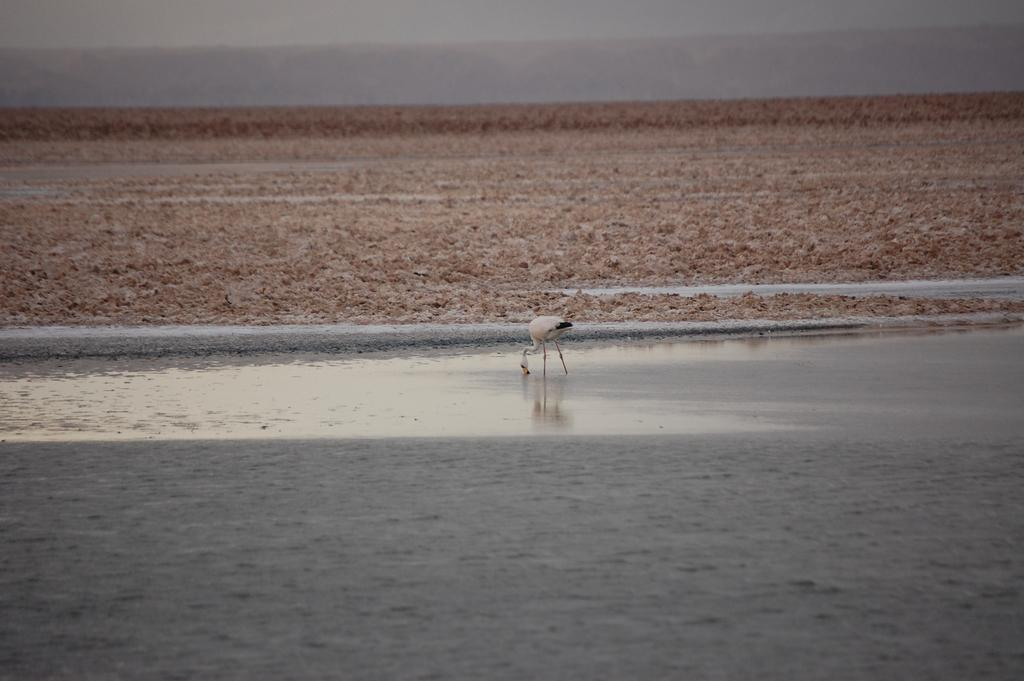What is the primary element present in the image? There is water in the image. What else can be seen in the image besides water? There is ground visible in the image. Are there any animals present in the image? Yes, there is a bird in the image. What is the color pattern of the bird? The bird is white and black in color. What is visible in the background of the image? The sky is visible in the background of the image. What type of knife is the bird using to cut the cracker in the image? There is no knife or cracker present in the image; it features a bird in water with a white and black color pattern. Is the bird wearing a stocking in the image? There is no indication of the bird wearing a stocking in the image. 